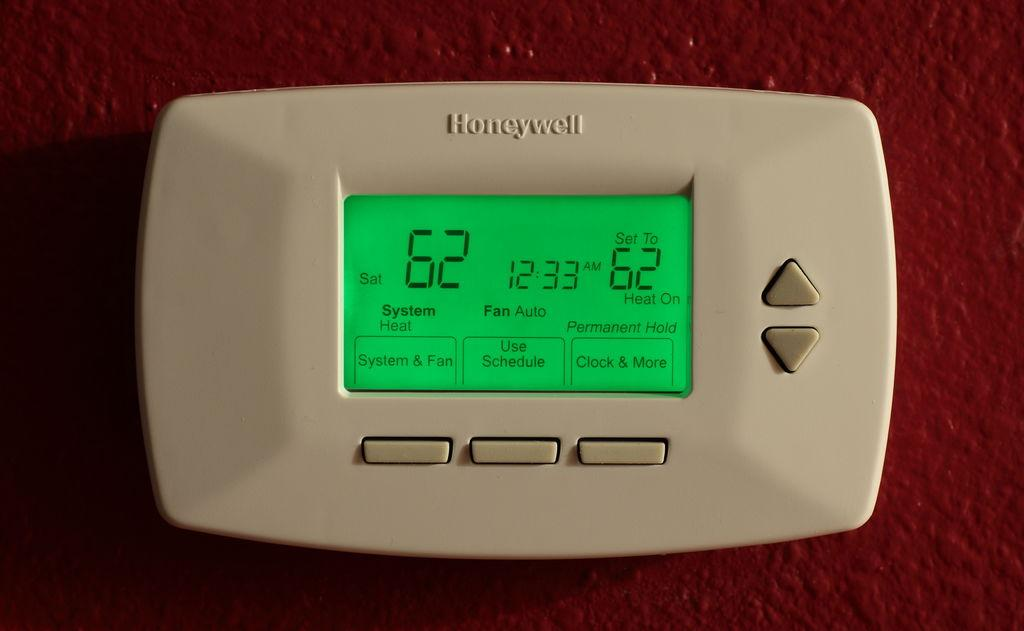<image>
Relay a brief, clear account of the picture shown. A rectangular device with Honeywell written on the top 